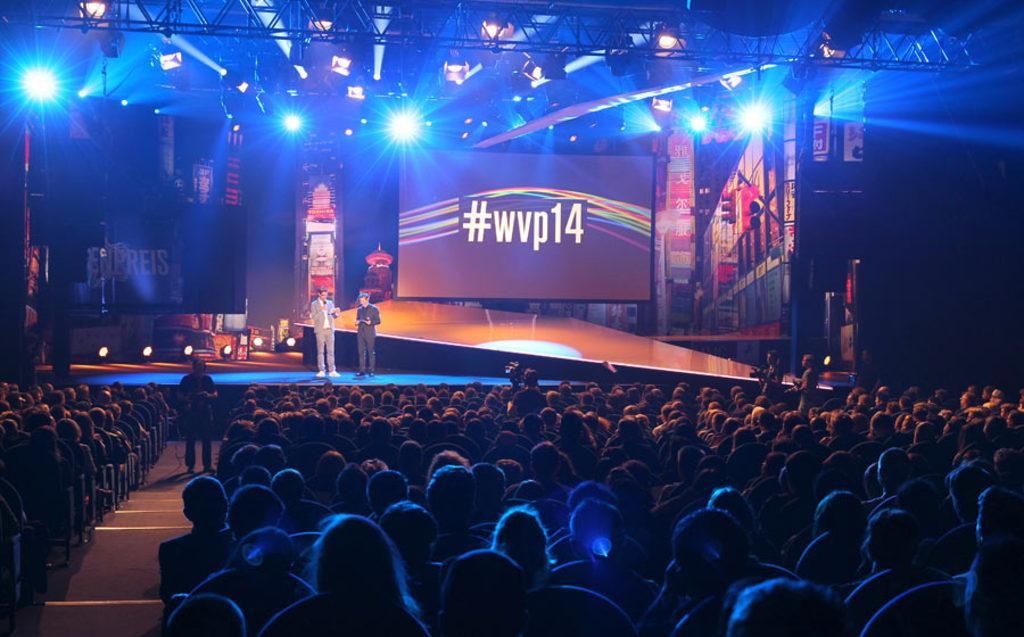How would you summarize this image in a sentence or two? This picture shows bunch of people seated on the chairs and we see a man Standing and holding a camera and recording and see another man standing on the side and we see couple of men Standing on the Dais and we see screen on the back and we see couple of them holding cameras on the side and standing. 